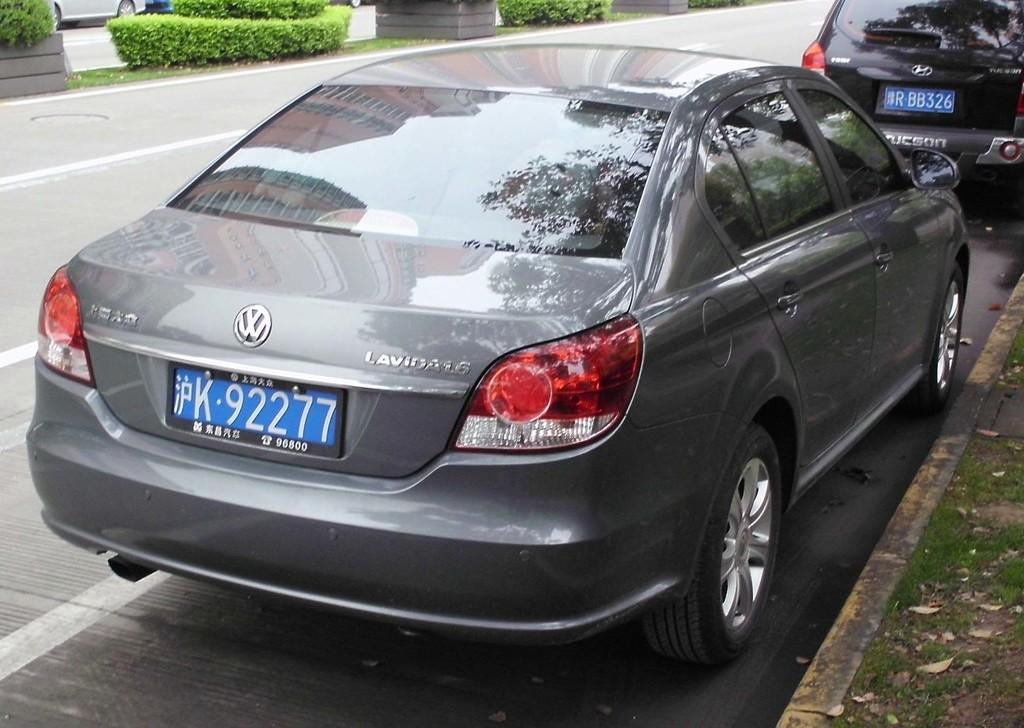<image>
Provide a brief description of the given image. A volkswagen lavida is parked on the street. 